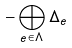Convert formula to latex. <formula><loc_0><loc_0><loc_500><loc_500>- \bigoplus _ { e \in \Lambda } \Delta _ { e }</formula> 